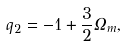Convert formula to latex. <formula><loc_0><loc_0><loc_500><loc_500>q _ { 2 } = - 1 + \frac { 3 } { 2 } \Omega _ { m } ,</formula> 